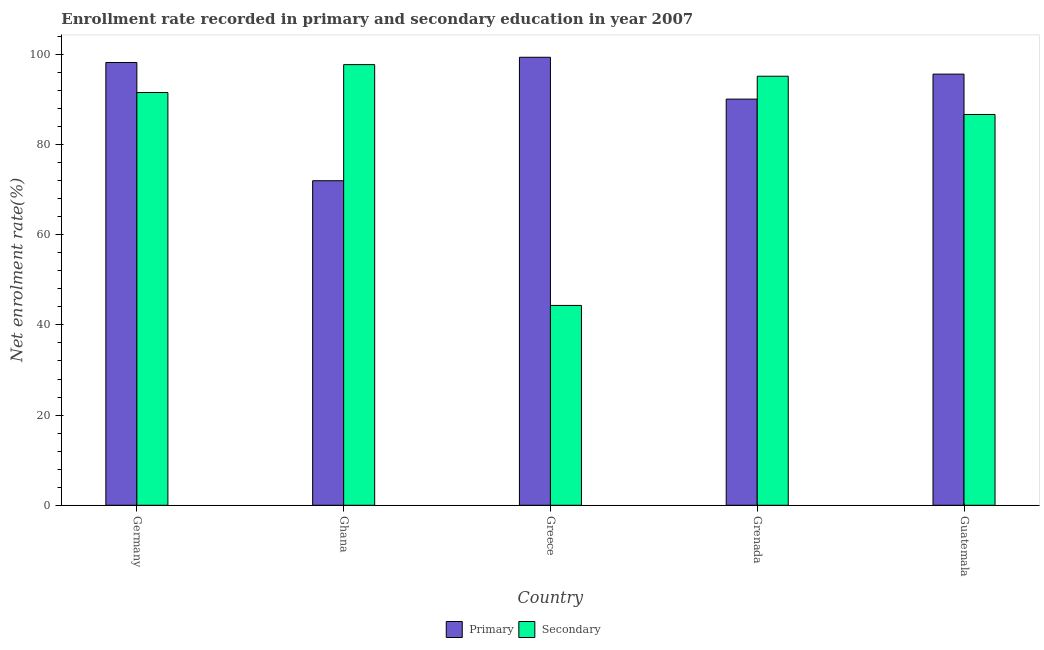How many different coloured bars are there?
Offer a very short reply. 2. Are the number of bars per tick equal to the number of legend labels?
Provide a short and direct response. Yes. Are the number of bars on each tick of the X-axis equal?
Ensure brevity in your answer.  Yes. What is the label of the 4th group of bars from the left?
Your response must be concise. Grenada. What is the enrollment rate in secondary education in Ghana?
Your answer should be very brief. 97.74. Across all countries, what is the maximum enrollment rate in primary education?
Your answer should be compact. 99.36. Across all countries, what is the minimum enrollment rate in primary education?
Your answer should be very brief. 71.98. In which country was the enrollment rate in primary education maximum?
Keep it short and to the point. Greece. In which country was the enrollment rate in secondary education minimum?
Keep it short and to the point. Greece. What is the total enrollment rate in secondary education in the graph?
Your answer should be compact. 415.45. What is the difference between the enrollment rate in secondary education in Germany and that in Guatemala?
Provide a succinct answer. 4.87. What is the difference between the enrollment rate in primary education in Ghana and the enrollment rate in secondary education in Germany?
Offer a terse response. -19.56. What is the average enrollment rate in secondary education per country?
Give a very brief answer. 83.09. What is the difference between the enrollment rate in secondary education and enrollment rate in primary education in Grenada?
Offer a terse response. 5.07. What is the ratio of the enrollment rate in secondary education in Germany to that in Guatemala?
Offer a terse response. 1.06. Is the difference between the enrollment rate in secondary education in Grenada and Guatemala greater than the difference between the enrollment rate in primary education in Grenada and Guatemala?
Your answer should be very brief. Yes. What is the difference between the highest and the second highest enrollment rate in primary education?
Your answer should be compact. 1.16. What is the difference between the highest and the lowest enrollment rate in secondary education?
Offer a very short reply. 53.41. In how many countries, is the enrollment rate in secondary education greater than the average enrollment rate in secondary education taken over all countries?
Provide a short and direct response. 4. Is the sum of the enrollment rate in primary education in Germany and Grenada greater than the maximum enrollment rate in secondary education across all countries?
Your answer should be very brief. Yes. What does the 1st bar from the left in Ghana represents?
Offer a terse response. Primary. What does the 1st bar from the right in Ghana represents?
Your answer should be compact. Secondary. How many bars are there?
Make the answer very short. 10. Are all the bars in the graph horizontal?
Ensure brevity in your answer.  No. How many countries are there in the graph?
Make the answer very short. 5. Does the graph contain any zero values?
Make the answer very short. No. Does the graph contain grids?
Make the answer very short. No. Where does the legend appear in the graph?
Make the answer very short. Bottom center. How are the legend labels stacked?
Give a very brief answer. Horizontal. What is the title of the graph?
Keep it short and to the point. Enrollment rate recorded in primary and secondary education in year 2007. What is the label or title of the X-axis?
Your answer should be compact. Country. What is the label or title of the Y-axis?
Your answer should be very brief. Net enrolment rate(%). What is the Net enrolment rate(%) of Primary in Germany?
Provide a short and direct response. 98.2. What is the Net enrolment rate(%) in Secondary in Germany?
Your answer should be very brief. 91.55. What is the Net enrolment rate(%) of Primary in Ghana?
Give a very brief answer. 71.98. What is the Net enrolment rate(%) in Secondary in Ghana?
Make the answer very short. 97.74. What is the Net enrolment rate(%) in Primary in Greece?
Your response must be concise. 99.36. What is the Net enrolment rate(%) in Secondary in Greece?
Your response must be concise. 44.32. What is the Net enrolment rate(%) of Primary in Grenada?
Your answer should be very brief. 90.09. What is the Net enrolment rate(%) of Secondary in Grenada?
Your answer should be compact. 95.16. What is the Net enrolment rate(%) in Primary in Guatemala?
Your response must be concise. 95.63. What is the Net enrolment rate(%) in Secondary in Guatemala?
Make the answer very short. 86.68. Across all countries, what is the maximum Net enrolment rate(%) of Primary?
Offer a very short reply. 99.36. Across all countries, what is the maximum Net enrolment rate(%) in Secondary?
Provide a succinct answer. 97.74. Across all countries, what is the minimum Net enrolment rate(%) of Primary?
Your response must be concise. 71.98. Across all countries, what is the minimum Net enrolment rate(%) of Secondary?
Keep it short and to the point. 44.32. What is the total Net enrolment rate(%) of Primary in the graph?
Ensure brevity in your answer.  455.27. What is the total Net enrolment rate(%) in Secondary in the graph?
Provide a succinct answer. 415.45. What is the difference between the Net enrolment rate(%) in Primary in Germany and that in Ghana?
Ensure brevity in your answer.  26.22. What is the difference between the Net enrolment rate(%) in Secondary in Germany and that in Ghana?
Give a very brief answer. -6.19. What is the difference between the Net enrolment rate(%) in Primary in Germany and that in Greece?
Provide a short and direct response. -1.16. What is the difference between the Net enrolment rate(%) in Secondary in Germany and that in Greece?
Offer a terse response. 47.22. What is the difference between the Net enrolment rate(%) in Primary in Germany and that in Grenada?
Make the answer very short. 8.12. What is the difference between the Net enrolment rate(%) in Secondary in Germany and that in Grenada?
Your response must be concise. -3.61. What is the difference between the Net enrolment rate(%) of Primary in Germany and that in Guatemala?
Provide a succinct answer. 2.57. What is the difference between the Net enrolment rate(%) in Secondary in Germany and that in Guatemala?
Keep it short and to the point. 4.87. What is the difference between the Net enrolment rate(%) of Primary in Ghana and that in Greece?
Keep it short and to the point. -27.38. What is the difference between the Net enrolment rate(%) in Secondary in Ghana and that in Greece?
Keep it short and to the point. 53.41. What is the difference between the Net enrolment rate(%) of Primary in Ghana and that in Grenada?
Provide a short and direct response. -18.1. What is the difference between the Net enrolment rate(%) of Secondary in Ghana and that in Grenada?
Provide a succinct answer. 2.58. What is the difference between the Net enrolment rate(%) in Primary in Ghana and that in Guatemala?
Make the answer very short. -23.65. What is the difference between the Net enrolment rate(%) of Secondary in Ghana and that in Guatemala?
Your response must be concise. 11.06. What is the difference between the Net enrolment rate(%) in Primary in Greece and that in Grenada?
Offer a very short reply. 9.28. What is the difference between the Net enrolment rate(%) of Secondary in Greece and that in Grenada?
Keep it short and to the point. -50.84. What is the difference between the Net enrolment rate(%) of Primary in Greece and that in Guatemala?
Provide a short and direct response. 3.74. What is the difference between the Net enrolment rate(%) in Secondary in Greece and that in Guatemala?
Provide a succinct answer. -42.35. What is the difference between the Net enrolment rate(%) in Primary in Grenada and that in Guatemala?
Offer a very short reply. -5.54. What is the difference between the Net enrolment rate(%) in Secondary in Grenada and that in Guatemala?
Provide a short and direct response. 8.48. What is the difference between the Net enrolment rate(%) of Primary in Germany and the Net enrolment rate(%) of Secondary in Ghana?
Offer a terse response. 0.47. What is the difference between the Net enrolment rate(%) in Primary in Germany and the Net enrolment rate(%) in Secondary in Greece?
Offer a terse response. 53.88. What is the difference between the Net enrolment rate(%) of Primary in Germany and the Net enrolment rate(%) of Secondary in Grenada?
Ensure brevity in your answer.  3.04. What is the difference between the Net enrolment rate(%) in Primary in Germany and the Net enrolment rate(%) in Secondary in Guatemala?
Keep it short and to the point. 11.53. What is the difference between the Net enrolment rate(%) of Primary in Ghana and the Net enrolment rate(%) of Secondary in Greece?
Provide a short and direct response. 27.66. What is the difference between the Net enrolment rate(%) in Primary in Ghana and the Net enrolment rate(%) in Secondary in Grenada?
Your response must be concise. -23.18. What is the difference between the Net enrolment rate(%) in Primary in Ghana and the Net enrolment rate(%) in Secondary in Guatemala?
Provide a short and direct response. -14.69. What is the difference between the Net enrolment rate(%) in Primary in Greece and the Net enrolment rate(%) in Secondary in Grenada?
Keep it short and to the point. 4.21. What is the difference between the Net enrolment rate(%) in Primary in Greece and the Net enrolment rate(%) in Secondary in Guatemala?
Give a very brief answer. 12.69. What is the difference between the Net enrolment rate(%) in Primary in Grenada and the Net enrolment rate(%) in Secondary in Guatemala?
Your answer should be compact. 3.41. What is the average Net enrolment rate(%) in Primary per country?
Provide a short and direct response. 91.05. What is the average Net enrolment rate(%) of Secondary per country?
Keep it short and to the point. 83.09. What is the difference between the Net enrolment rate(%) of Primary and Net enrolment rate(%) of Secondary in Germany?
Offer a terse response. 6.66. What is the difference between the Net enrolment rate(%) of Primary and Net enrolment rate(%) of Secondary in Ghana?
Your answer should be very brief. -25.75. What is the difference between the Net enrolment rate(%) of Primary and Net enrolment rate(%) of Secondary in Greece?
Your answer should be compact. 55.04. What is the difference between the Net enrolment rate(%) in Primary and Net enrolment rate(%) in Secondary in Grenada?
Your answer should be very brief. -5.07. What is the difference between the Net enrolment rate(%) of Primary and Net enrolment rate(%) of Secondary in Guatemala?
Your answer should be compact. 8.95. What is the ratio of the Net enrolment rate(%) in Primary in Germany to that in Ghana?
Your answer should be very brief. 1.36. What is the ratio of the Net enrolment rate(%) in Secondary in Germany to that in Ghana?
Your answer should be very brief. 0.94. What is the ratio of the Net enrolment rate(%) in Primary in Germany to that in Greece?
Provide a succinct answer. 0.99. What is the ratio of the Net enrolment rate(%) of Secondary in Germany to that in Greece?
Your answer should be compact. 2.07. What is the ratio of the Net enrolment rate(%) of Primary in Germany to that in Grenada?
Provide a short and direct response. 1.09. What is the ratio of the Net enrolment rate(%) of Primary in Germany to that in Guatemala?
Give a very brief answer. 1.03. What is the ratio of the Net enrolment rate(%) of Secondary in Germany to that in Guatemala?
Give a very brief answer. 1.06. What is the ratio of the Net enrolment rate(%) of Primary in Ghana to that in Greece?
Make the answer very short. 0.72. What is the ratio of the Net enrolment rate(%) in Secondary in Ghana to that in Greece?
Offer a terse response. 2.21. What is the ratio of the Net enrolment rate(%) of Primary in Ghana to that in Grenada?
Ensure brevity in your answer.  0.8. What is the ratio of the Net enrolment rate(%) of Secondary in Ghana to that in Grenada?
Provide a succinct answer. 1.03. What is the ratio of the Net enrolment rate(%) of Primary in Ghana to that in Guatemala?
Offer a very short reply. 0.75. What is the ratio of the Net enrolment rate(%) of Secondary in Ghana to that in Guatemala?
Provide a short and direct response. 1.13. What is the ratio of the Net enrolment rate(%) of Primary in Greece to that in Grenada?
Your answer should be compact. 1.1. What is the ratio of the Net enrolment rate(%) in Secondary in Greece to that in Grenada?
Keep it short and to the point. 0.47. What is the ratio of the Net enrolment rate(%) of Primary in Greece to that in Guatemala?
Make the answer very short. 1.04. What is the ratio of the Net enrolment rate(%) of Secondary in Greece to that in Guatemala?
Your answer should be compact. 0.51. What is the ratio of the Net enrolment rate(%) in Primary in Grenada to that in Guatemala?
Provide a short and direct response. 0.94. What is the ratio of the Net enrolment rate(%) of Secondary in Grenada to that in Guatemala?
Provide a succinct answer. 1.1. What is the difference between the highest and the second highest Net enrolment rate(%) in Primary?
Your response must be concise. 1.16. What is the difference between the highest and the second highest Net enrolment rate(%) of Secondary?
Give a very brief answer. 2.58. What is the difference between the highest and the lowest Net enrolment rate(%) of Primary?
Provide a succinct answer. 27.38. What is the difference between the highest and the lowest Net enrolment rate(%) in Secondary?
Ensure brevity in your answer.  53.41. 